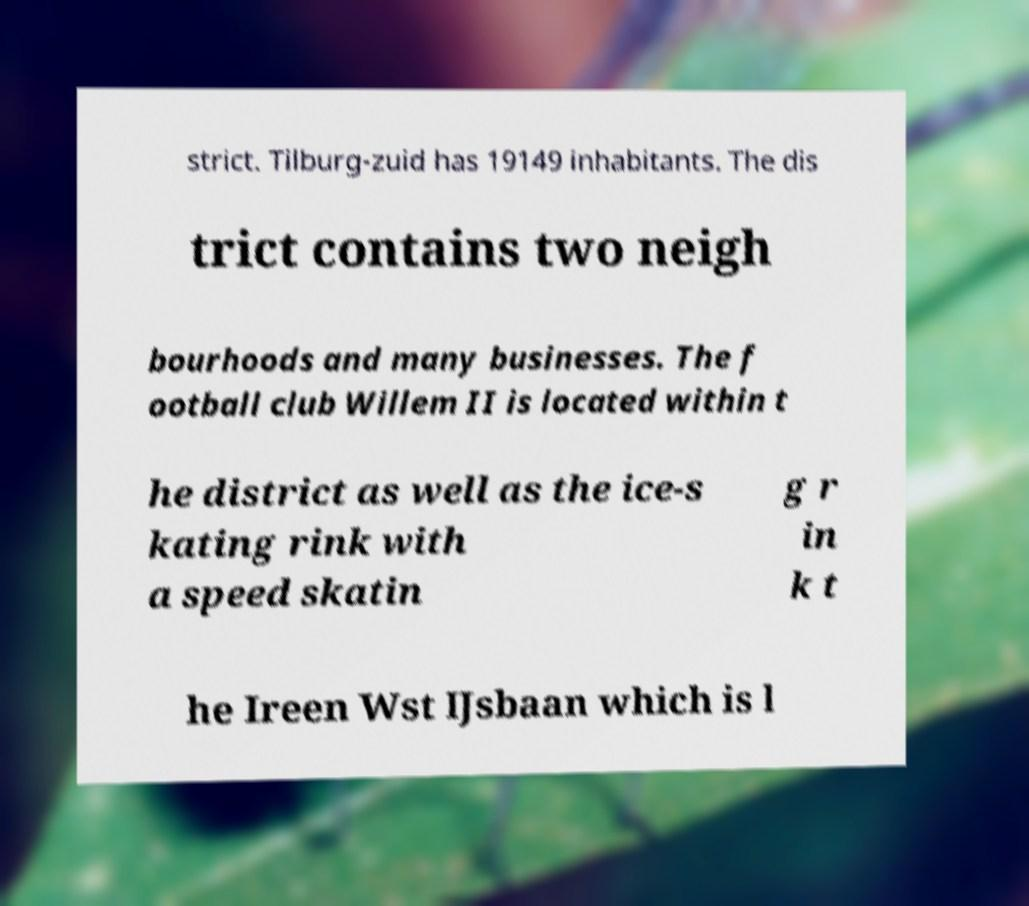For documentation purposes, I need the text within this image transcribed. Could you provide that? strict. Tilburg-zuid has 19149 inhabitants. The dis trict contains two neigh bourhoods and many businesses. The f ootball club Willem II is located within t he district as well as the ice-s kating rink with a speed skatin g r in k t he Ireen Wst IJsbaan which is l 